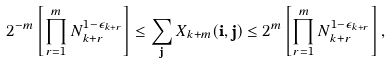Convert formula to latex. <formula><loc_0><loc_0><loc_500><loc_500>2 ^ { - m } \left [ \prod _ { r = 1 } ^ { m } N _ { k + r } ^ { 1 - \epsilon _ { k + r } } \right ] \leq \sum _ { \mathbf j } X _ { k + m } ( \mathbf i , \mathbf j ) \leq 2 ^ { m } \left [ \prod _ { r = 1 } ^ { m } N _ { k + r } ^ { 1 - \epsilon _ { k + r } } \right ] ,</formula> 